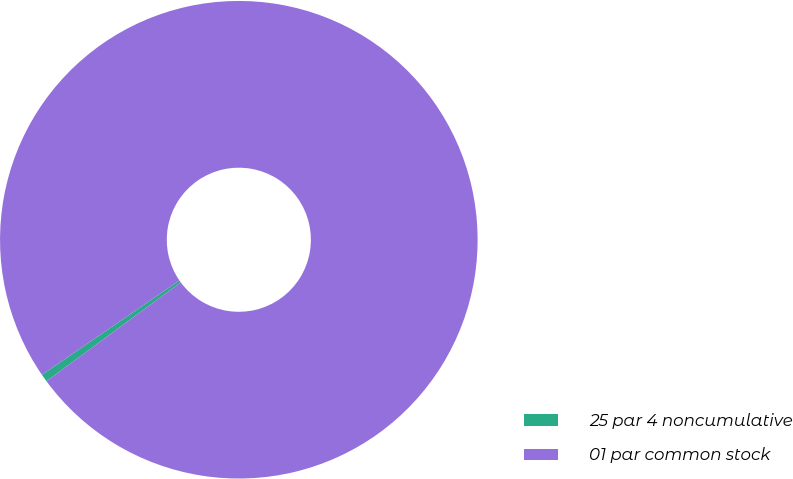Convert chart. <chart><loc_0><loc_0><loc_500><loc_500><pie_chart><fcel>25 par 4 noncumulative<fcel>01 par common stock<nl><fcel>0.52%<fcel>99.48%<nl></chart> 